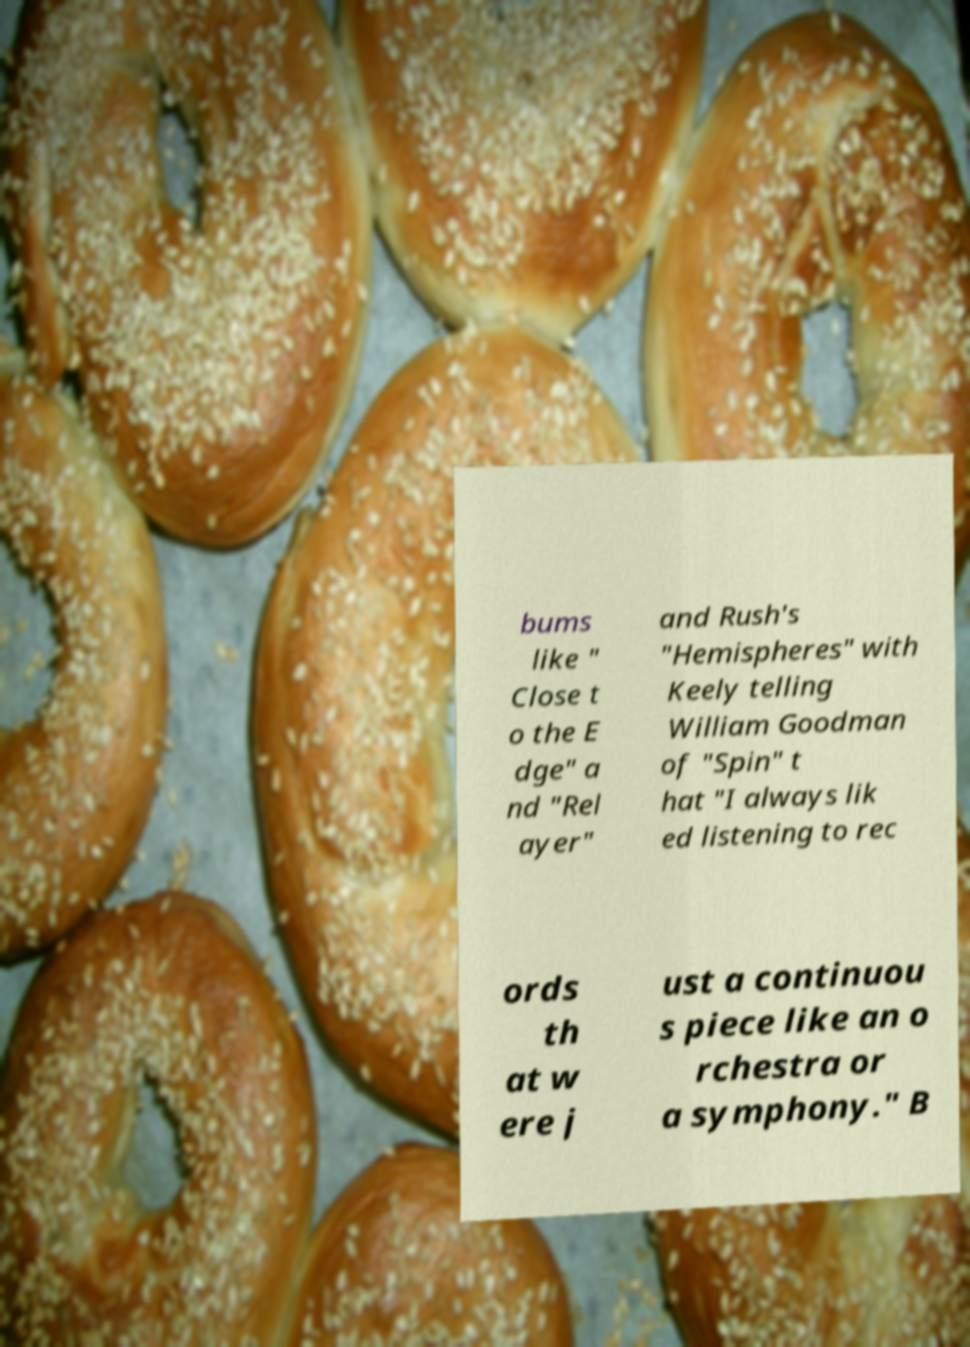Could you extract and type out the text from this image? bums like " Close t o the E dge" a nd "Rel ayer" and Rush's "Hemispheres" with Keely telling William Goodman of "Spin" t hat "I always lik ed listening to rec ords th at w ere j ust a continuou s piece like an o rchestra or a symphony." B 